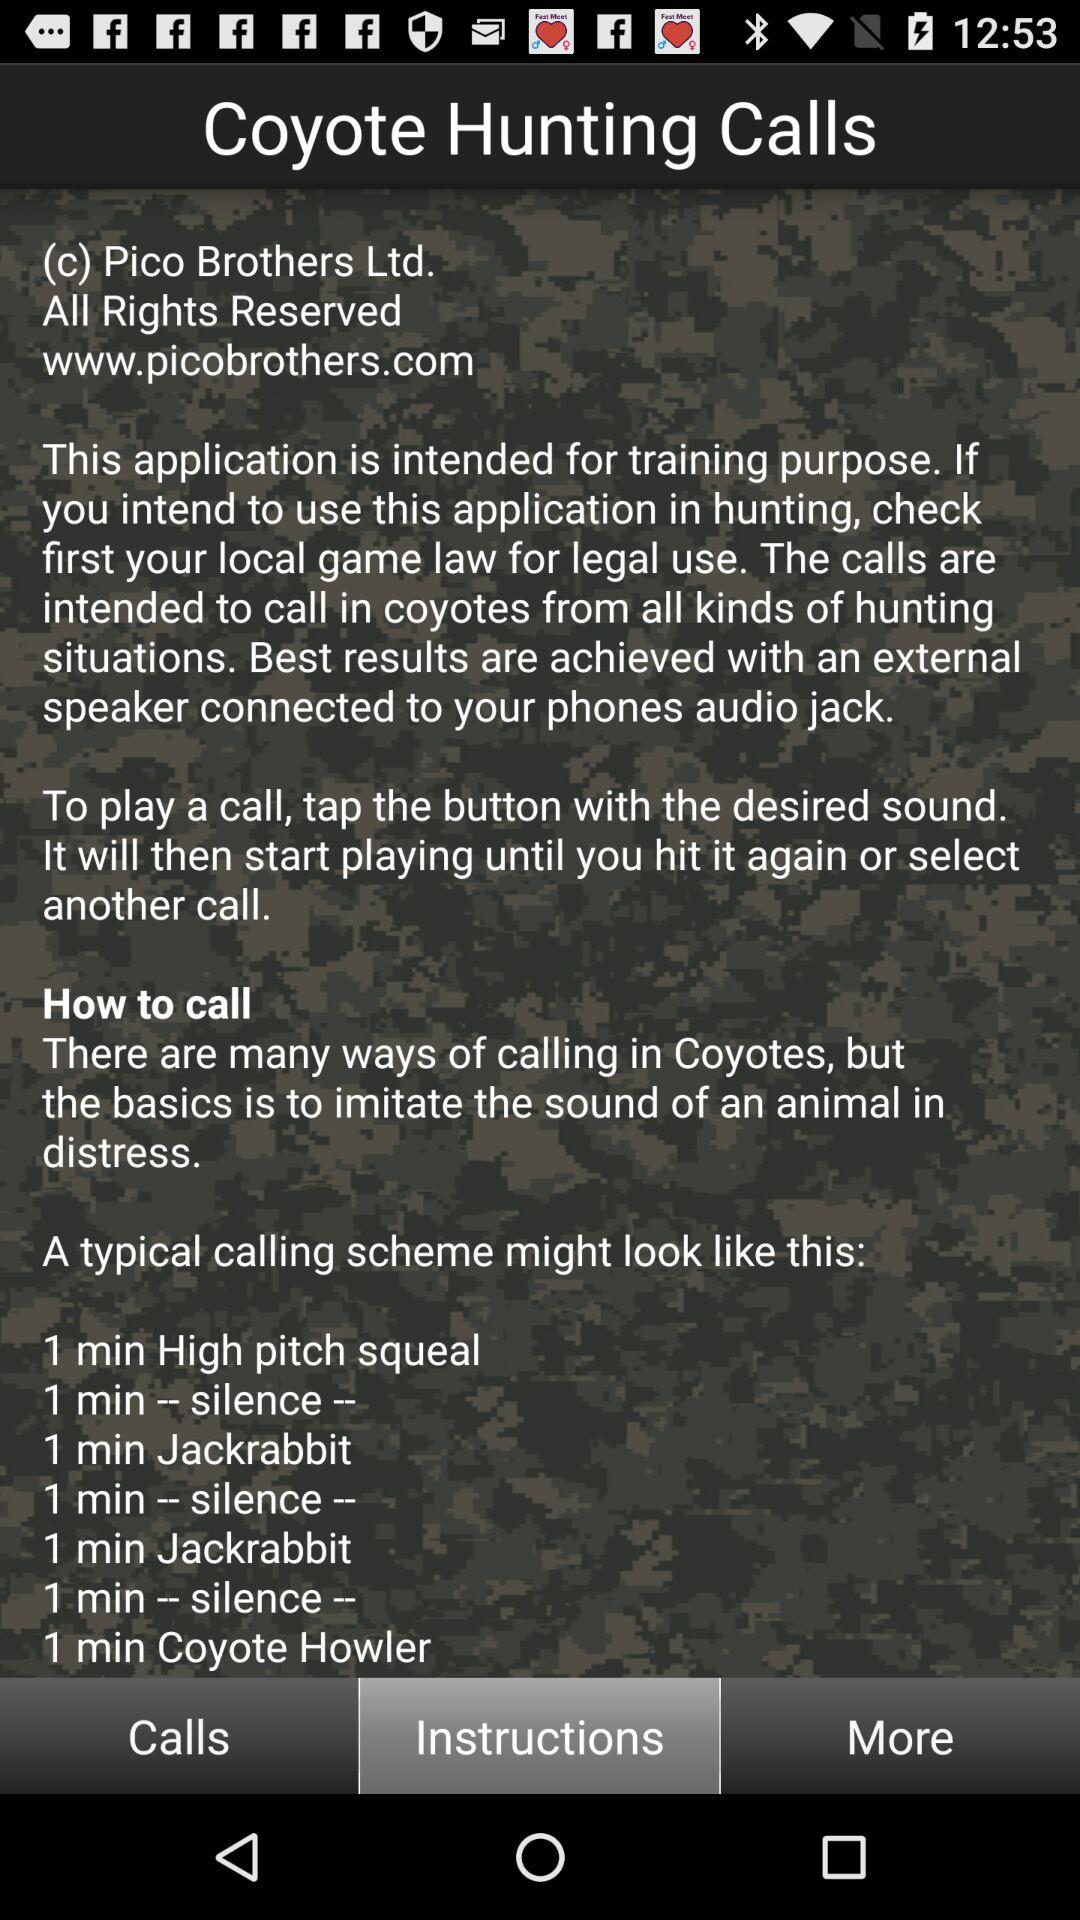Which tab is selected right now? The tab that is selected right now is "Instructions". 